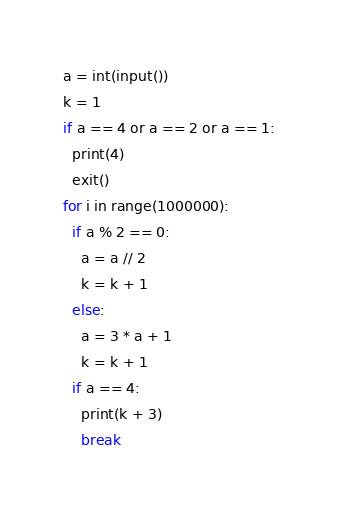<code> <loc_0><loc_0><loc_500><loc_500><_Python_>a = int(input())
k = 1
if a == 4 or a == 2 or a == 1:
  print(4)
  exit()
for i in range(1000000):
  if a % 2 == 0:
    a = a // 2
    k = k + 1
  else:
    a = 3 * a + 1
    k = k + 1
  if a == 4:
    print(k + 3)
    break</code> 